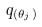Convert formula to latex. <formula><loc_0><loc_0><loc_500><loc_500>q _ { ( \theta _ { j } ) }</formula> 